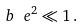Convert formula to latex. <formula><loc_0><loc_0><loc_500><loc_500>b \ e ^ { 2 } \ll 1 \, .</formula> 